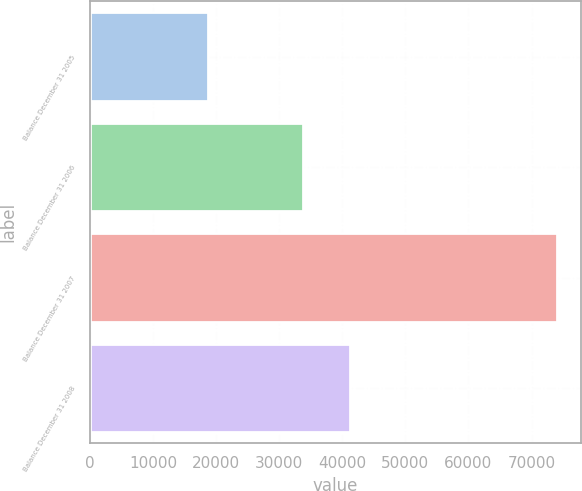<chart> <loc_0><loc_0><loc_500><loc_500><bar_chart><fcel>Balance December 31 2005<fcel>Balance December 31 2006<fcel>Balance December 31 2007<fcel>Balance December 31 2008<nl><fcel>18684<fcel>33794<fcel>74061<fcel>41215<nl></chart> 